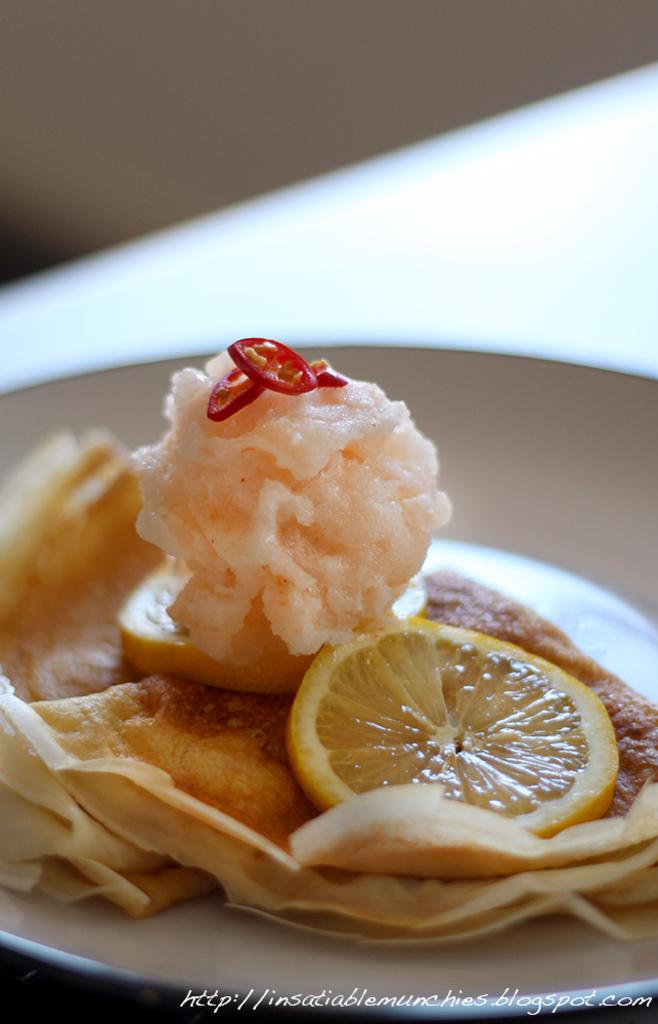What is present on the plate in the image? There is food in a plate in the image. How many rings are visible on the plate in the image? There are no rings present on the plate in the image. What type of rabbits can be seen playing with the food on the plate? There are no rabbits present in the image; it only features a plate of food. 